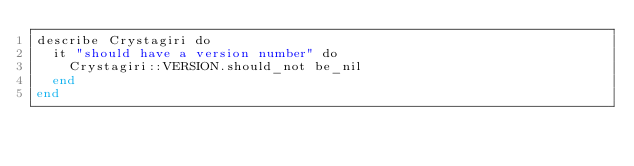<code> <loc_0><loc_0><loc_500><loc_500><_Crystal_>describe Crystagiri do
  it "should have a version number" do
    Crystagiri::VERSION.should_not be_nil
  end
end
</code> 